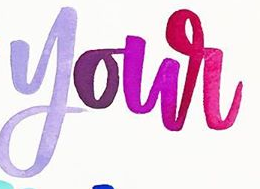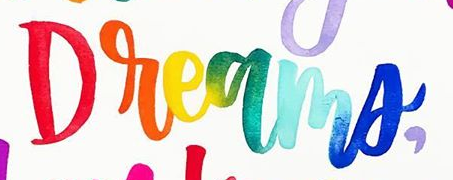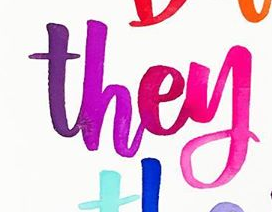What text appears in these images from left to right, separated by a semicolon? your; Dreams,; they 